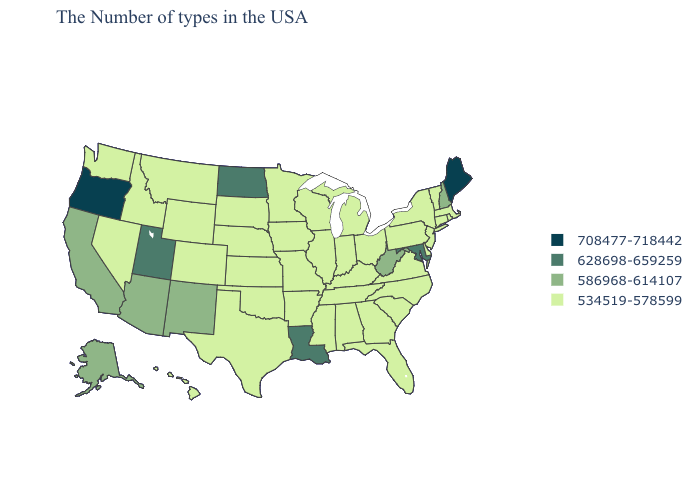Does Delaware have a higher value than Missouri?
Short answer required. No. Does Arkansas have the same value as Texas?
Quick response, please. Yes. Is the legend a continuous bar?
Write a very short answer. No. Name the states that have a value in the range 628698-659259?
Quick response, please. Maryland, Louisiana, North Dakota, Utah. How many symbols are there in the legend?
Answer briefly. 4. What is the highest value in the Northeast ?
Short answer required. 708477-718442. Among the states that border New Mexico , which have the highest value?
Quick response, please. Utah. Does West Virginia have the lowest value in the South?
Short answer required. No. What is the highest value in the West ?
Quick response, please. 708477-718442. What is the lowest value in the South?
Give a very brief answer. 534519-578599. Name the states that have a value in the range 708477-718442?
Concise answer only. Maine, Oregon. Does Maine have the highest value in the USA?
Write a very short answer. Yes. What is the value of South Dakota?
Concise answer only. 534519-578599. 